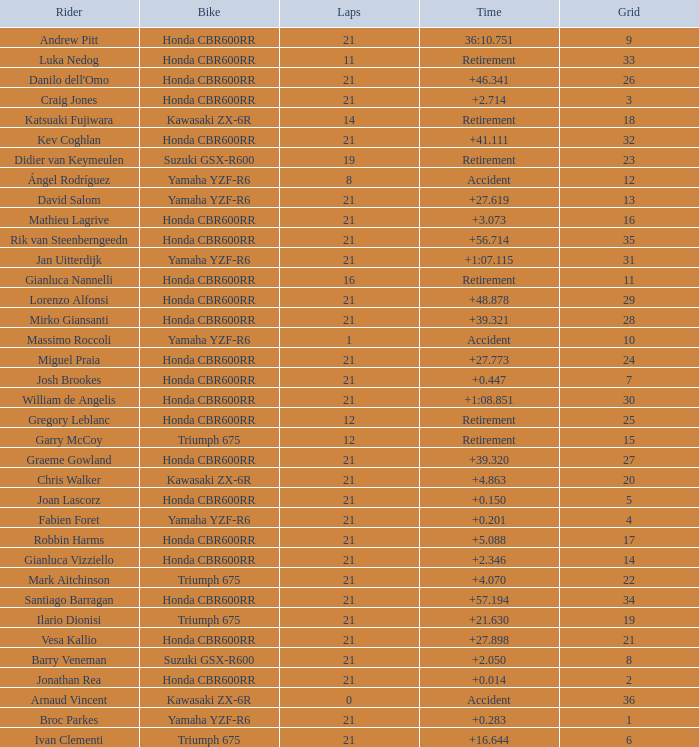What is the driver with the laps under 16, grid of 10, a bike of Yamaha YZF-R6, and ended with an accident? Massimo Roccoli. I'm looking to parse the entire table for insights. Could you assist me with that? {'header': ['Rider', 'Bike', 'Laps', 'Time', 'Grid'], 'rows': [['Andrew Pitt', 'Honda CBR600RR', '21', '36:10.751', '9'], ['Luka Nedog', 'Honda CBR600RR', '11', 'Retirement', '33'], ["Danilo dell'Omo", 'Honda CBR600RR', '21', '+46.341', '26'], ['Craig Jones', 'Honda CBR600RR', '21', '+2.714', '3'], ['Katsuaki Fujiwara', 'Kawasaki ZX-6R', '14', 'Retirement', '18'], ['Kev Coghlan', 'Honda CBR600RR', '21', '+41.111', '32'], ['Didier van Keymeulen', 'Suzuki GSX-R600', '19', 'Retirement', '23'], ['Ángel Rodríguez', 'Yamaha YZF-R6', '8', 'Accident', '12'], ['David Salom', 'Yamaha YZF-R6', '21', '+27.619', '13'], ['Mathieu Lagrive', 'Honda CBR600RR', '21', '+3.073', '16'], ['Rik van Steenberngeedn', 'Honda CBR600RR', '21', '+56.714', '35'], ['Jan Uitterdijk', 'Yamaha YZF-R6', '21', '+1:07.115', '31'], ['Gianluca Nannelli', 'Honda CBR600RR', '16', 'Retirement', '11'], ['Lorenzo Alfonsi', 'Honda CBR600RR', '21', '+48.878', '29'], ['Mirko Giansanti', 'Honda CBR600RR', '21', '+39.321', '28'], ['Massimo Roccoli', 'Yamaha YZF-R6', '1', 'Accident', '10'], ['Miguel Praia', 'Honda CBR600RR', '21', '+27.773', '24'], ['Josh Brookes', 'Honda CBR600RR', '21', '+0.447', '7'], ['William de Angelis', 'Honda CBR600RR', '21', '+1:08.851', '30'], ['Gregory Leblanc', 'Honda CBR600RR', '12', 'Retirement', '25'], ['Garry McCoy', 'Triumph 675', '12', 'Retirement', '15'], ['Graeme Gowland', 'Honda CBR600RR', '21', '+39.320', '27'], ['Chris Walker', 'Kawasaki ZX-6R', '21', '+4.863', '20'], ['Joan Lascorz', 'Honda CBR600RR', '21', '+0.150', '5'], ['Fabien Foret', 'Yamaha YZF-R6', '21', '+0.201', '4'], ['Robbin Harms', 'Honda CBR600RR', '21', '+5.088', '17'], ['Gianluca Vizziello', 'Honda CBR600RR', '21', '+2.346', '14'], ['Mark Aitchinson', 'Triumph 675', '21', '+4.070', '22'], ['Santiago Barragan', 'Honda CBR600RR', '21', '+57.194', '34'], ['Ilario Dionisi', 'Triumph 675', '21', '+21.630', '19'], ['Vesa Kallio', 'Honda CBR600RR', '21', '+27.898', '21'], ['Barry Veneman', 'Suzuki GSX-R600', '21', '+2.050', '8'], ['Jonathan Rea', 'Honda CBR600RR', '21', '+0.014', '2'], ['Arnaud Vincent', 'Kawasaki ZX-6R', '0', 'Accident', '36'], ['Broc Parkes', 'Yamaha YZF-R6', '21', '+0.283', '1'], ['Ivan Clementi', 'Triumph 675', '21', '+16.644', '6']]} 